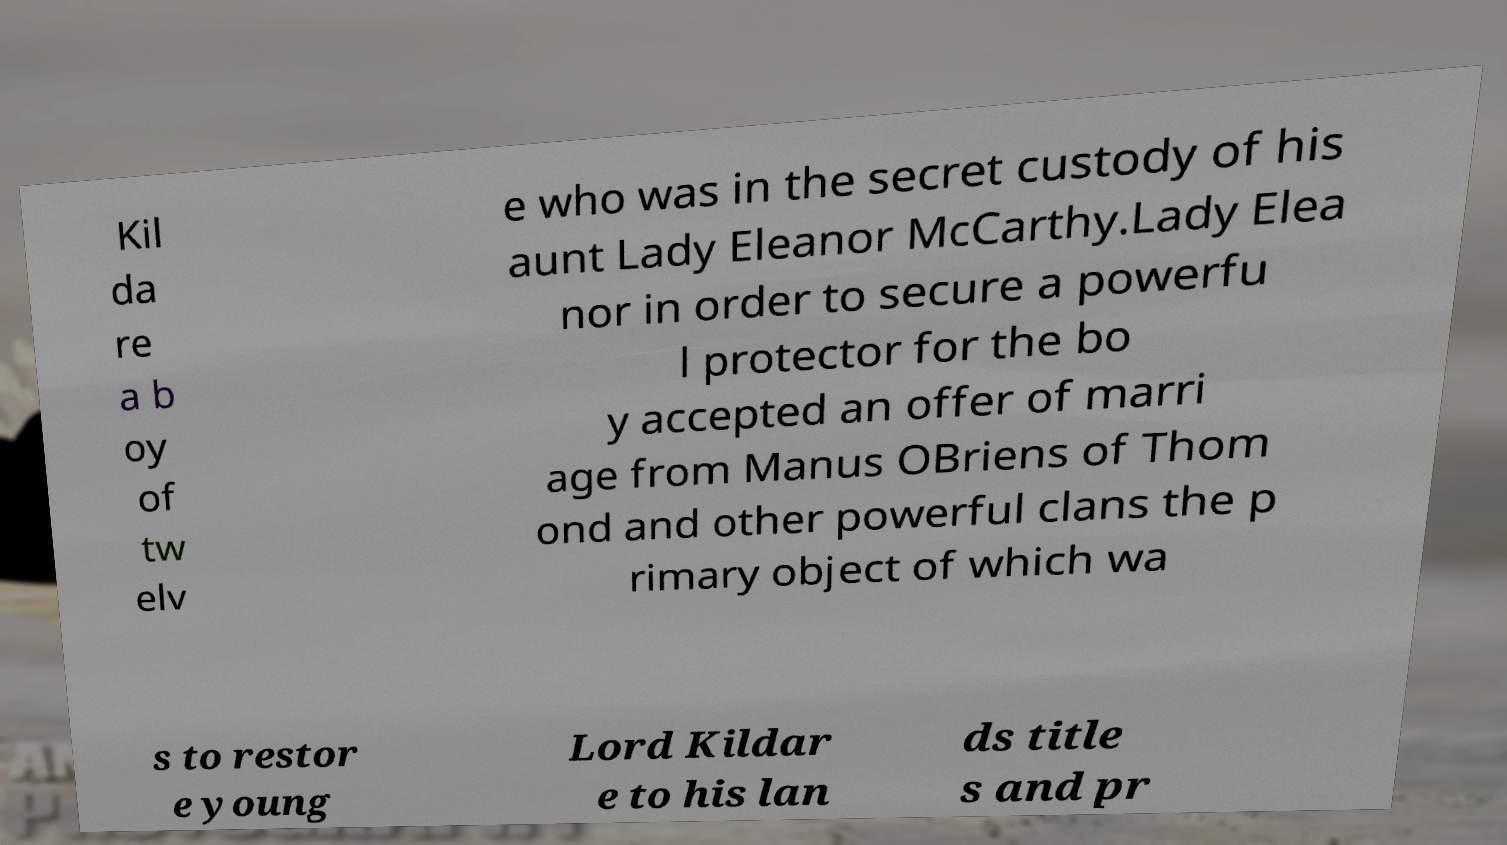For documentation purposes, I need the text within this image transcribed. Could you provide that? Kil da re a b oy of tw elv e who was in the secret custody of his aunt Lady Eleanor McCarthy.Lady Elea nor in order to secure a powerfu l protector for the bo y accepted an offer of marri age from Manus OBriens of Thom ond and other powerful clans the p rimary object of which wa s to restor e young Lord Kildar e to his lan ds title s and pr 